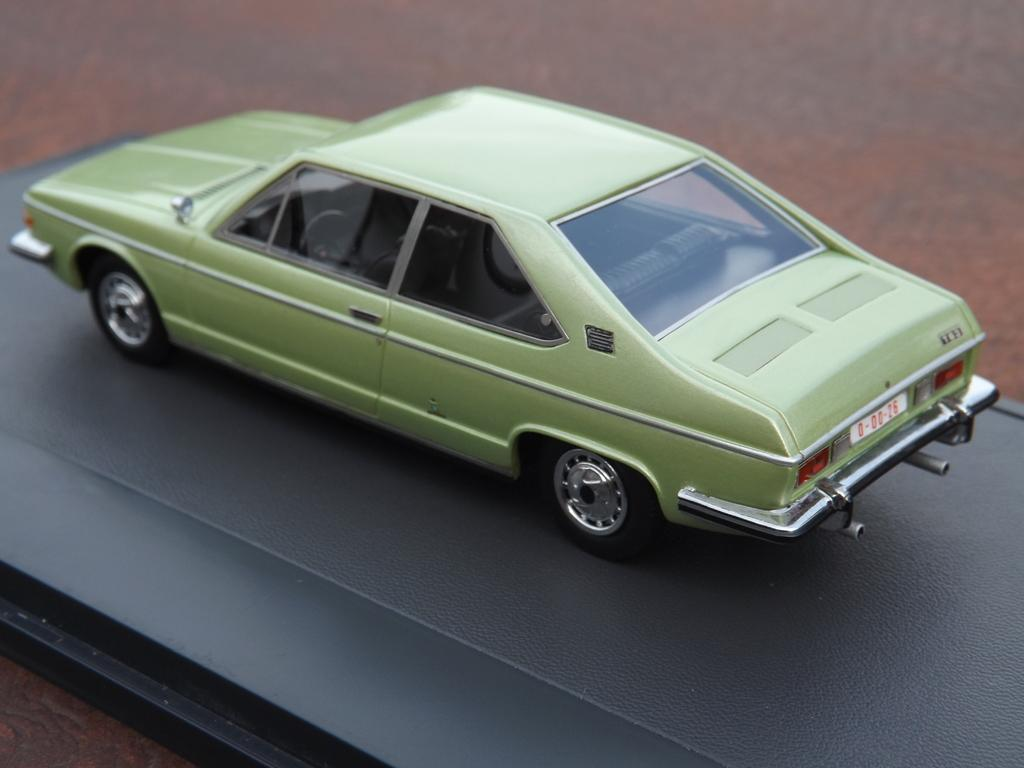What is the background color of the image? The image is on a black surface. What is the main subject of the image? There is a vehicle in the image. What feature of the vehicle is mentioned in the facts? The vehicle has wheels and a number plate. How many crows are sitting on the steel frame in the image? There is no steel frame or crows present in the image; it features a vehicle on a black surface. 